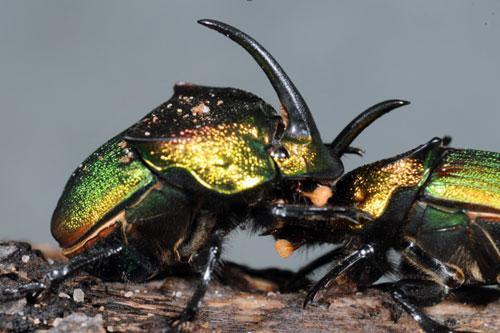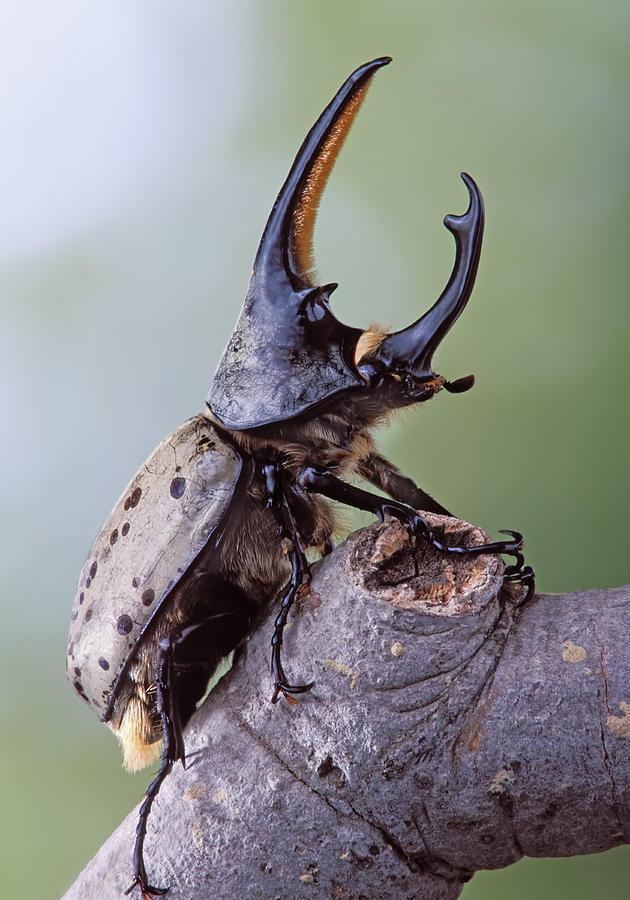The first image is the image on the left, the second image is the image on the right. Assess this claim about the two images: "One dung beetle is completely on top of a piece of wood.". Correct or not? Answer yes or no. Yes. The first image is the image on the left, the second image is the image on the right. For the images displayed, is the sentence "There are at least three beetles." factually correct? Answer yes or no. Yes. 